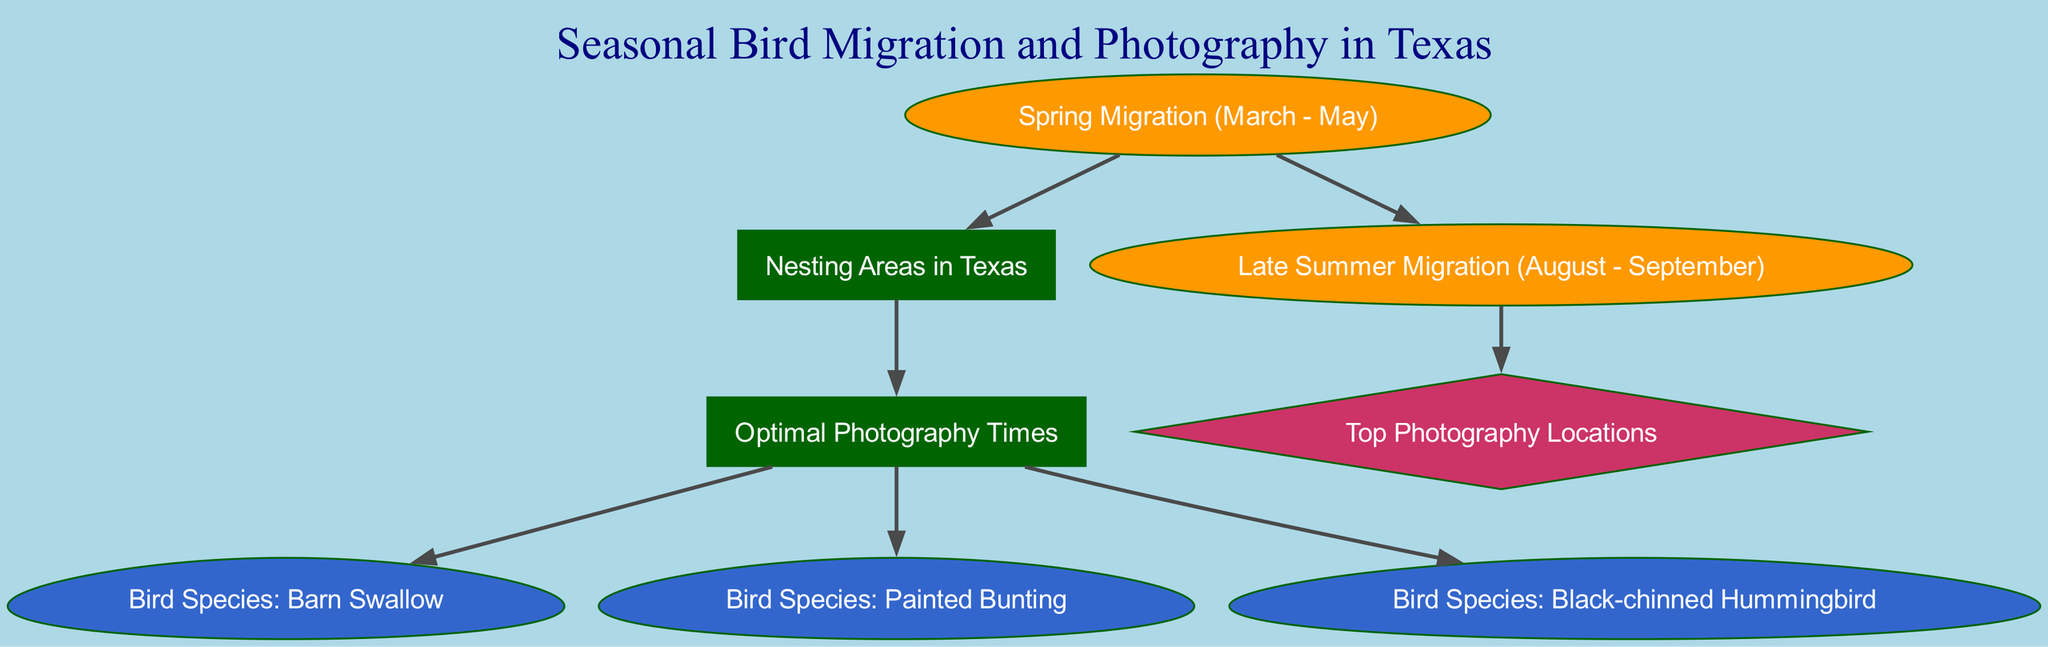What are the two migration periods represented in the diagram? The diagram shows two migration periods: "Spring Migration (March - May)" and "Late Summer Migration (August - September)". These are clearly labeled as separate nodes in the directed graph.
Answer: Spring Migration, Late Summer Migration How many bird species can be found in Texas according to the diagram? The diagram displays three bird species: "Barn Swallow", "Painted Bunting", and "Black-chinned Hummingbird". Counting these nodes gives a result of three species.
Answer: Three What follows the "Nesting Areas in Texas" node in the diagram? The "Nesting Areas in Texas" node connects to the "Optimal Photography Times" node directly in the diagram, indicating the relationship between nesting and the best times for photography.
Answer: Optimal Photography Times Which bird species has the most direct edge connections in the diagram? Each bird species node ("Barn Swallow", "Painted Bunting", "Black-chinned Hummingbird") has one edge connecting it to "Optimal Photography Times". Since they all connect in the same way, no single species has more connections than the others. Thus, the answer is that there is no bird species with more connections.
Answer: None What is the significance of the node labeled "Top Photography Locations"? This node is connected to "Late Summer Migration", indicating that it represents the best spots for photography after the birds have migrated during the late summer period. It is important for photography enthusiasts wanting to capture images during this time.
Answer: Best photography spots 